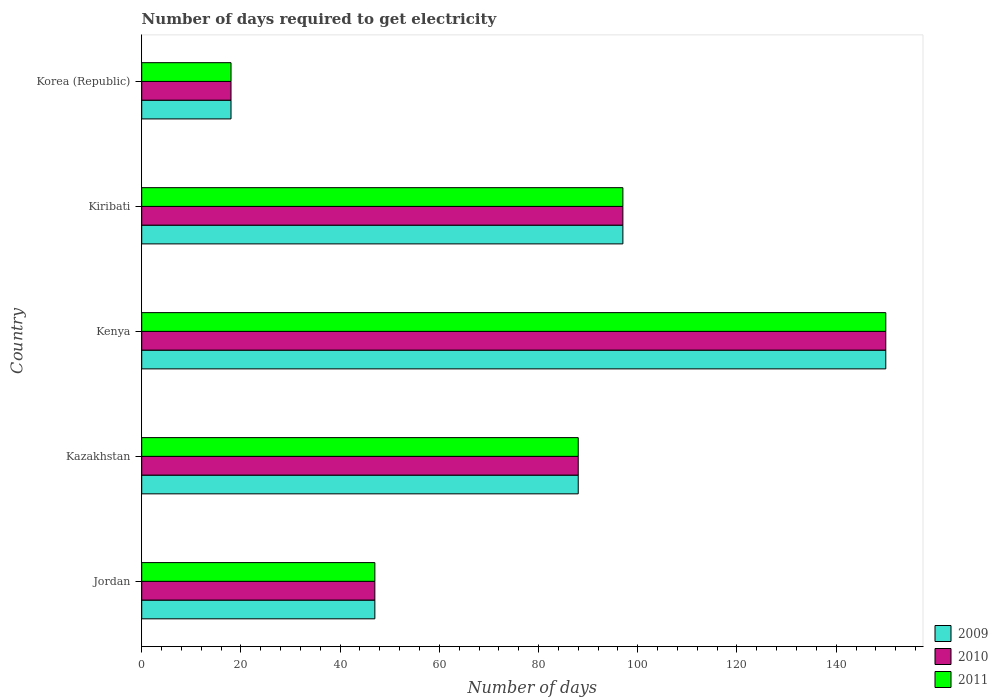Are the number of bars per tick equal to the number of legend labels?
Make the answer very short. Yes. Are the number of bars on each tick of the Y-axis equal?
Ensure brevity in your answer.  Yes. How many bars are there on the 4th tick from the top?
Make the answer very short. 3. How many bars are there on the 2nd tick from the bottom?
Make the answer very short. 3. What is the label of the 5th group of bars from the top?
Provide a short and direct response. Jordan. In how many cases, is the number of bars for a given country not equal to the number of legend labels?
Make the answer very short. 0. What is the number of days required to get electricity in in 2009 in Kenya?
Give a very brief answer. 150. Across all countries, what is the maximum number of days required to get electricity in in 2011?
Give a very brief answer. 150. In which country was the number of days required to get electricity in in 2010 maximum?
Make the answer very short. Kenya. In which country was the number of days required to get electricity in in 2009 minimum?
Your response must be concise. Korea (Republic). What is the total number of days required to get electricity in in 2010 in the graph?
Your response must be concise. 400. What is the difference between the number of days required to get electricity in in 2009 in Kazakhstan and that in Kenya?
Your response must be concise. -62. What is the difference between the number of days required to get electricity in in 2010 in Jordan and the number of days required to get electricity in in 2011 in Kenya?
Your answer should be very brief. -103. What is the average number of days required to get electricity in in 2010 per country?
Offer a very short reply. 80. What is the ratio of the number of days required to get electricity in in 2010 in Jordan to that in Kenya?
Your answer should be compact. 0.31. Is the number of days required to get electricity in in 2009 in Kenya less than that in Korea (Republic)?
Offer a very short reply. No. What is the difference between the highest and the lowest number of days required to get electricity in in 2011?
Offer a terse response. 132. In how many countries, is the number of days required to get electricity in in 2010 greater than the average number of days required to get electricity in in 2010 taken over all countries?
Your response must be concise. 3. What does the 2nd bar from the bottom in Kenya represents?
Make the answer very short. 2010. How many bars are there?
Your answer should be compact. 15. What is the difference between two consecutive major ticks on the X-axis?
Make the answer very short. 20. Does the graph contain grids?
Make the answer very short. No. Where does the legend appear in the graph?
Your response must be concise. Bottom right. What is the title of the graph?
Your answer should be compact. Number of days required to get electricity. Does "1993" appear as one of the legend labels in the graph?
Give a very brief answer. No. What is the label or title of the X-axis?
Your answer should be very brief. Number of days. What is the Number of days in 2009 in Jordan?
Offer a terse response. 47. What is the Number of days of 2011 in Jordan?
Provide a short and direct response. 47. What is the Number of days in 2009 in Kazakhstan?
Offer a terse response. 88. What is the Number of days of 2011 in Kazakhstan?
Offer a terse response. 88. What is the Number of days in 2009 in Kenya?
Give a very brief answer. 150. What is the Number of days of 2010 in Kenya?
Your response must be concise. 150. What is the Number of days of 2011 in Kenya?
Give a very brief answer. 150. What is the Number of days of 2009 in Kiribati?
Your response must be concise. 97. What is the Number of days of 2010 in Kiribati?
Your answer should be compact. 97. What is the Number of days of 2011 in Kiribati?
Your answer should be compact. 97. Across all countries, what is the maximum Number of days in 2009?
Provide a short and direct response. 150. Across all countries, what is the maximum Number of days in 2010?
Give a very brief answer. 150. Across all countries, what is the maximum Number of days of 2011?
Your answer should be compact. 150. Across all countries, what is the minimum Number of days in 2009?
Your answer should be compact. 18. Across all countries, what is the minimum Number of days of 2011?
Your answer should be compact. 18. What is the total Number of days of 2009 in the graph?
Your answer should be very brief. 400. What is the total Number of days of 2010 in the graph?
Make the answer very short. 400. What is the difference between the Number of days in 2009 in Jordan and that in Kazakhstan?
Provide a short and direct response. -41. What is the difference between the Number of days in 2010 in Jordan and that in Kazakhstan?
Give a very brief answer. -41. What is the difference between the Number of days in 2011 in Jordan and that in Kazakhstan?
Keep it short and to the point. -41. What is the difference between the Number of days of 2009 in Jordan and that in Kenya?
Offer a terse response. -103. What is the difference between the Number of days in 2010 in Jordan and that in Kenya?
Ensure brevity in your answer.  -103. What is the difference between the Number of days in 2011 in Jordan and that in Kenya?
Your response must be concise. -103. What is the difference between the Number of days in 2010 in Jordan and that in Kiribati?
Provide a succinct answer. -50. What is the difference between the Number of days in 2009 in Jordan and that in Korea (Republic)?
Offer a terse response. 29. What is the difference between the Number of days in 2011 in Jordan and that in Korea (Republic)?
Your response must be concise. 29. What is the difference between the Number of days in 2009 in Kazakhstan and that in Kenya?
Ensure brevity in your answer.  -62. What is the difference between the Number of days of 2010 in Kazakhstan and that in Kenya?
Provide a succinct answer. -62. What is the difference between the Number of days of 2011 in Kazakhstan and that in Kenya?
Ensure brevity in your answer.  -62. What is the difference between the Number of days of 2009 in Kazakhstan and that in Kiribati?
Your answer should be very brief. -9. What is the difference between the Number of days of 2011 in Kazakhstan and that in Kiribati?
Give a very brief answer. -9. What is the difference between the Number of days of 2009 in Kazakhstan and that in Korea (Republic)?
Give a very brief answer. 70. What is the difference between the Number of days in 2010 in Kazakhstan and that in Korea (Republic)?
Provide a succinct answer. 70. What is the difference between the Number of days in 2011 in Kazakhstan and that in Korea (Republic)?
Your response must be concise. 70. What is the difference between the Number of days of 2009 in Kenya and that in Kiribati?
Your answer should be compact. 53. What is the difference between the Number of days of 2010 in Kenya and that in Kiribati?
Your response must be concise. 53. What is the difference between the Number of days of 2011 in Kenya and that in Kiribati?
Your response must be concise. 53. What is the difference between the Number of days of 2009 in Kenya and that in Korea (Republic)?
Your answer should be compact. 132. What is the difference between the Number of days of 2010 in Kenya and that in Korea (Republic)?
Keep it short and to the point. 132. What is the difference between the Number of days of 2011 in Kenya and that in Korea (Republic)?
Give a very brief answer. 132. What is the difference between the Number of days in 2009 in Kiribati and that in Korea (Republic)?
Your answer should be compact. 79. What is the difference between the Number of days of 2010 in Kiribati and that in Korea (Republic)?
Provide a succinct answer. 79. What is the difference between the Number of days of 2011 in Kiribati and that in Korea (Republic)?
Offer a very short reply. 79. What is the difference between the Number of days in 2009 in Jordan and the Number of days in 2010 in Kazakhstan?
Provide a short and direct response. -41. What is the difference between the Number of days in 2009 in Jordan and the Number of days in 2011 in Kazakhstan?
Offer a terse response. -41. What is the difference between the Number of days of 2010 in Jordan and the Number of days of 2011 in Kazakhstan?
Offer a terse response. -41. What is the difference between the Number of days in 2009 in Jordan and the Number of days in 2010 in Kenya?
Ensure brevity in your answer.  -103. What is the difference between the Number of days of 2009 in Jordan and the Number of days of 2011 in Kenya?
Offer a very short reply. -103. What is the difference between the Number of days in 2010 in Jordan and the Number of days in 2011 in Kenya?
Make the answer very short. -103. What is the difference between the Number of days in 2009 in Jordan and the Number of days in 2010 in Kiribati?
Provide a short and direct response. -50. What is the difference between the Number of days in 2010 in Jordan and the Number of days in 2011 in Kiribati?
Make the answer very short. -50. What is the difference between the Number of days in 2009 in Jordan and the Number of days in 2010 in Korea (Republic)?
Provide a succinct answer. 29. What is the difference between the Number of days in 2010 in Jordan and the Number of days in 2011 in Korea (Republic)?
Give a very brief answer. 29. What is the difference between the Number of days of 2009 in Kazakhstan and the Number of days of 2010 in Kenya?
Offer a very short reply. -62. What is the difference between the Number of days in 2009 in Kazakhstan and the Number of days in 2011 in Kenya?
Offer a terse response. -62. What is the difference between the Number of days in 2010 in Kazakhstan and the Number of days in 2011 in Kenya?
Ensure brevity in your answer.  -62. What is the difference between the Number of days of 2009 in Kazakhstan and the Number of days of 2011 in Kiribati?
Your answer should be very brief. -9. What is the difference between the Number of days in 2009 in Kazakhstan and the Number of days in 2010 in Korea (Republic)?
Keep it short and to the point. 70. What is the difference between the Number of days of 2009 in Kazakhstan and the Number of days of 2011 in Korea (Republic)?
Keep it short and to the point. 70. What is the difference between the Number of days in 2009 in Kenya and the Number of days in 2010 in Kiribati?
Give a very brief answer. 53. What is the difference between the Number of days in 2009 in Kenya and the Number of days in 2011 in Kiribati?
Provide a short and direct response. 53. What is the difference between the Number of days of 2009 in Kenya and the Number of days of 2010 in Korea (Republic)?
Give a very brief answer. 132. What is the difference between the Number of days of 2009 in Kenya and the Number of days of 2011 in Korea (Republic)?
Offer a very short reply. 132. What is the difference between the Number of days of 2010 in Kenya and the Number of days of 2011 in Korea (Republic)?
Ensure brevity in your answer.  132. What is the difference between the Number of days of 2009 in Kiribati and the Number of days of 2010 in Korea (Republic)?
Your answer should be very brief. 79. What is the difference between the Number of days in 2009 in Kiribati and the Number of days in 2011 in Korea (Republic)?
Provide a short and direct response. 79. What is the difference between the Number of days in 2010 in Kiribati and the Number of days in 2011 in Korea (Republic)?
Your answer should be very brief. 79. What is the average Number of days of 2009 per country?
Provide a succinct answer. 80. What is the average Number of days in 2011 per country?
Your answer should be very brief. 80. What is the difference between the Number of days of 2009 and Number of days of 2011 in Jordan?
Your answer should be compact. 0. What is the difference between the Number of days in 2010 and Number of days in 2011 in Jordan?
Make the answer very short. 0. What is the difference between the Number of days of 2010 and Number of days of 2011 in Kazakhstan?
Provide a succinct answer. 0. What is the difference between the Number of days in 2009 and Number of days in 2010 in Kenya?
Provide a short and direct response. 0. What is the difference between the Number of days in 2010 and Number of days in 2011 in Kenya?
Provide a short and direct response. 0. What is the difference between the Number of days of 2009 and Number of days of 2010 in Kiribati?
Ensure brevity in your answer.  0. What is the difference between the Number of days of 2009 and Number of days of 2011 in Korea (Republic)?
Your answer should be compact. 0. What is the ratio of the Number of days of 2009 in Jordan to that in Kazakhstan?
Offer a terse response. 0.53. What is the ratio of the Number of days in 2010 in Jordan to that in Kazakhstan?
Offer a terse response. 0.53. What is the ratio of the Number of days of 2011 in Jordan to that in Kazakhstan?
Your response must be concise. 0.53. What is the ratio of the Number of days of 2009 in Jordan to that in Kenya?
Your answer should be very brief. 0.31. What is the ratio of the Number of days of 2010 in Jordan to that in Kenya?
Offer a very short reply. 0.31. What is the ratio of the Number of days of 2011 in Jordan to that in Kenya?
Offer a very short reply. 0.31. What is the ratio of the Number of days of 2009 in Jordan to that in Kiribati?
Keep it short and to the point. 0.48. What is the ratio of the Number of days in 2010 in Jordan to that in Kiribati?
Provide a short and direct response. 0.48. What is the ratio of the Number of days in 2011 in Jordan to that in Kiribati?
Ensure brevity in your answer.  0.48. What is the ratio of the Number of days in 2009 in Jordan to that in Korea (Republic)?
Make the answer very short. 2.61. What is the ratio of the Number of days of 2010 in Jordan to that in Korea (Republic)?
Offer a terse response. 2.61. What is the ratio of the Number of days in 2011 in Jordan to that in Korea (Republic)?
Give a very brief answer. 2.61. What is the ratio of the Number of days in 2009 in Kazakhstan to that in Kenya?
Ensure brevity in your answer.  0.59. What is the ratio of the Number of days of 2010 in Kazakhstan to that in Kenya?
Provide a short and direct response. 0.59. What is the ratio of the Number of days of 2011 in Kazakhstan to that in Kenya?
Your answer should be compact. 0.59. What is the ratio of the Number of days in 2009 in Kazakhstan to that in Kiribati?
Provide a succinct answer. 0.91. What is the ratio of the Number of days in 2010 in Kazakhstan to that in Kiribati?
Offer a very short reply. 0.91. What is the ratio of the Number of days of 2011 in Kazakhstan to that in Kiribati?
Provide a succinct answer. 0.91. What is the ratio of the Number of days in 2009 in Kazakhstan to that in Korea (Republic)?
Offer a terse response. 4.89. What is the ratio of the Number of days of 2010 in Kazakhstan to that in Korea (Republic)?
Make the answer very short. 4.89. What is the ratio of the Number of days of 2011 in Kazakhstan to that in Korea (Republic)?
Provide a succinct answer. 4.89. What is the ratio of the Number of days of 2009 in Kenya to that in Kiribati?
Offer a very short reply. 1.55. What is the ratio of the Number of days in 2010 in Kenya to that in Kiribati?
Your response must be concise. 1.55. What is the ratio of the Number of days in 2011 in Kenya to that in Kiribati?
Your answer should be compact. 1.55. What is the ratio of the Number of days of 2009 in Kenya to that in Korea (Republic)?
Give a very brief answer. 8.33. What is the ratio of the Number of days of 2010 in Kenya to that in Korea (Republic)?
Provide a succinct answer. 8.33. What is the ratio of the Number of days in 2011 in Kenya to that in Korea (Republic)?
Provide a short and direct response. 8.33. What is the ratio of the Number of days of 2009 in Kiribati to that in Korea (Republic)?
Your answer should be very brief. 5.39. What is the ratio of the Number of days in 2010 in Kiribati to that in Korea (Republic)?
Offer a terse response. 5.39. What is the ratio of the Number of days of 2011 in Kiribati to that in Korea (Republic)?
Give a very brief answer. 5.39. What is the difference between the highest and the second highest Number of days of 2011?
Offer a very short reply. 53. What is the difference between the highest and the lowest Number of days in 2009?
Make the answer very short. 132. What is the difference between the highest and the lowest Number of days in 2010?
Give a very brief answer. 132. What is the difference between the highest and the lowest Number of days in 2011?
Provide a short and direct response. 132. 